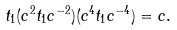Convert formula to latex. <formula><loc_0><loc_0><loc_500><loc_500>t _ { 1 } ( c ^ { 2 } t _ { 1 } c ^ { - 2 } ) ( c ^ { 4 } t _ { 1 } c ^ { - 4 } ) = c .</formula> 